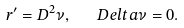<formula> <loc_0><loc_0><loc_500><loc_500>r ^ { \prime } = D ^ { 2 } \nu , \ \ \ D e l t a \nu = 0 .</formula> 